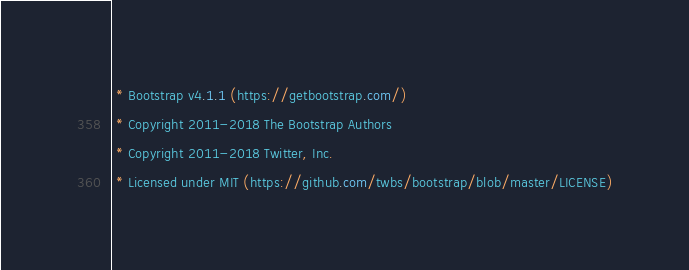<code> <loc_0><loc_0><loc_500><loc_500><_CSS_> * Bootstrap v4.1.1 (https://getbootstrap.com/)
 * Copyright 2011-2018 The Bootstrap Authors
 * Copyright 2011-2018 Twitter, Inc.
 * Licensed under MIT (https://github.com/twbs/bootstrap/blob/master/LICENSE)</code> 